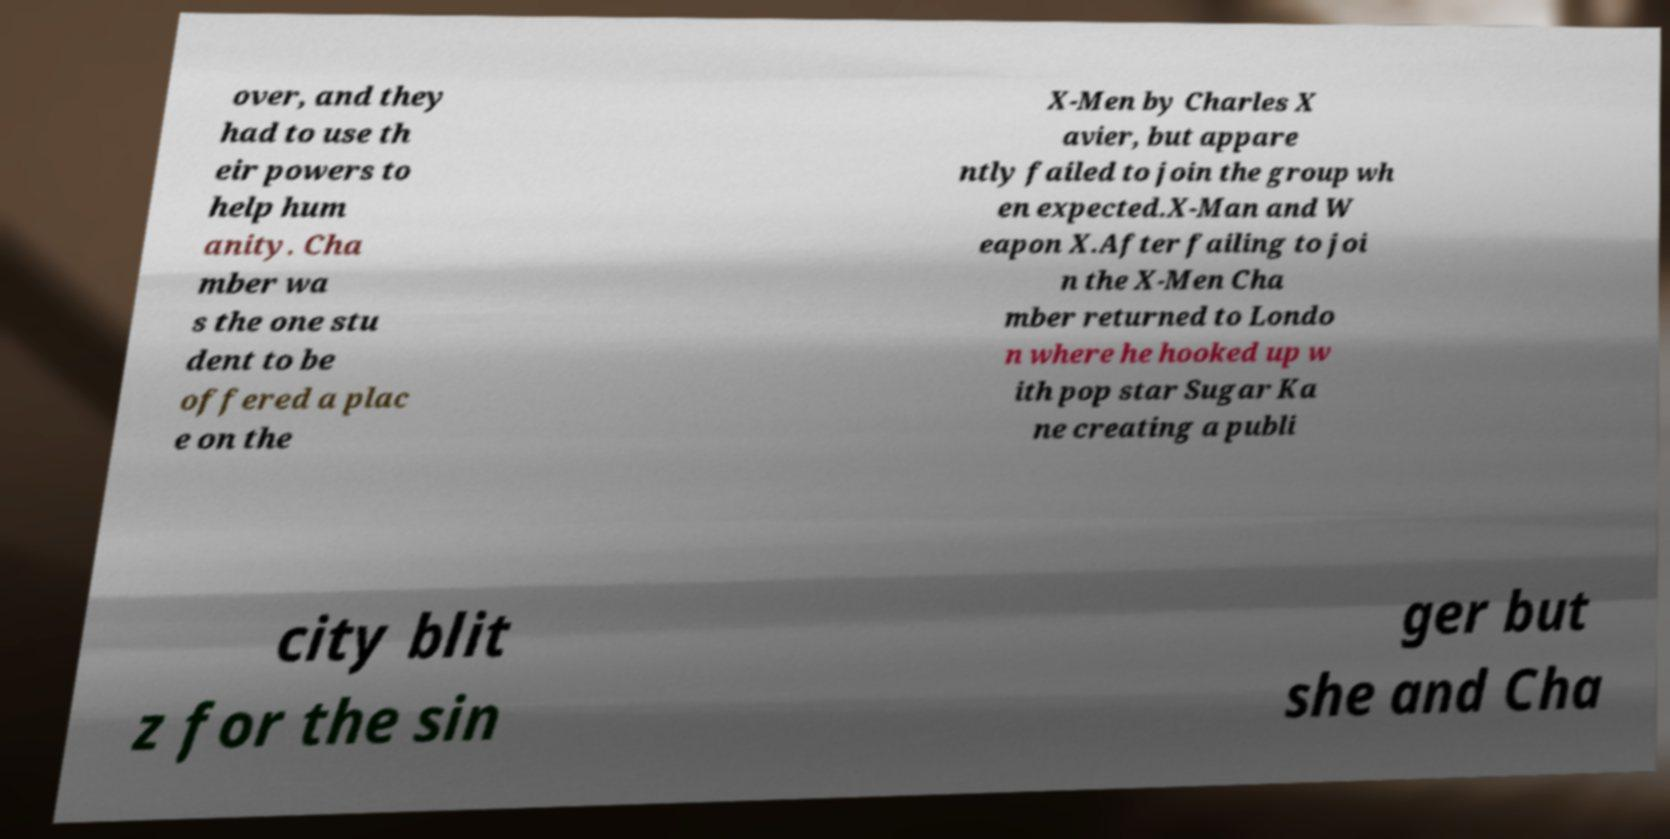Please read and relay the text visible in this image. What does it say? over, and they had to use th eir powers to help hum anity. Cha mber wa s the one stu dent to be offered a plac e on the X-Men by Charles X avier, but appare ntly failed to join the group wh en expected.X-Man and W eapon X.After failing to joi n the X-Men Cha mber returned to Londo n where he hooked up w ith pop star Sugar Ka ne creating a publi city blit z for the sin ger but she and Cha 